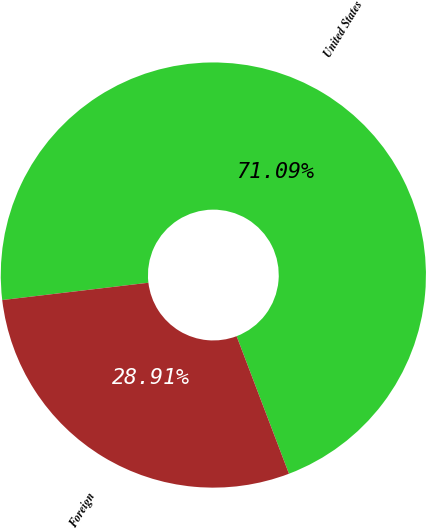Convert chart to OTSL. <chart><loc_0><loc_0><loc_500><loc_500><pie_chart><fcel>United States<fcel>Foreign<nl><fcel>71.09%<fcel>28.91%<nl></chart> 